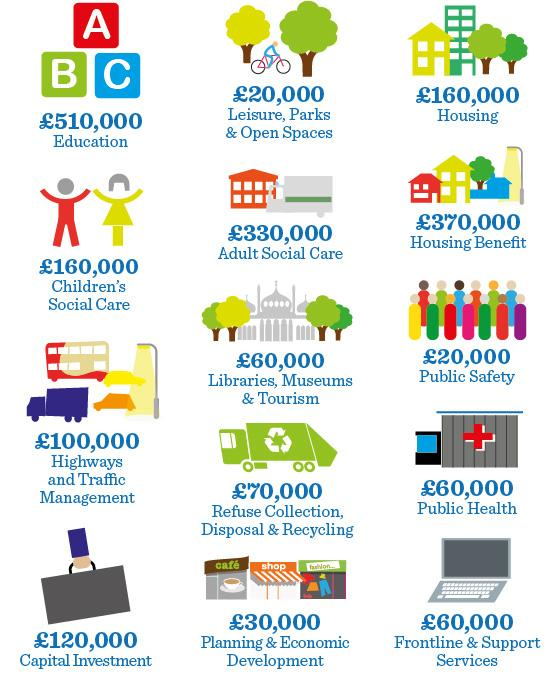Give some essential details in this illustration. The total amount for housing benefit and public safety is 390,000 pounds. The suitcase is grey. The contents of the shop boards in the Planning & Economic Development department include the words 'cafe', 'shop', and 'fashion'. The total amount in Public Health and Frontline & Support Services is 120,000 pounds. The man is riding a bicycle in leisure, parks, and open spaces. 